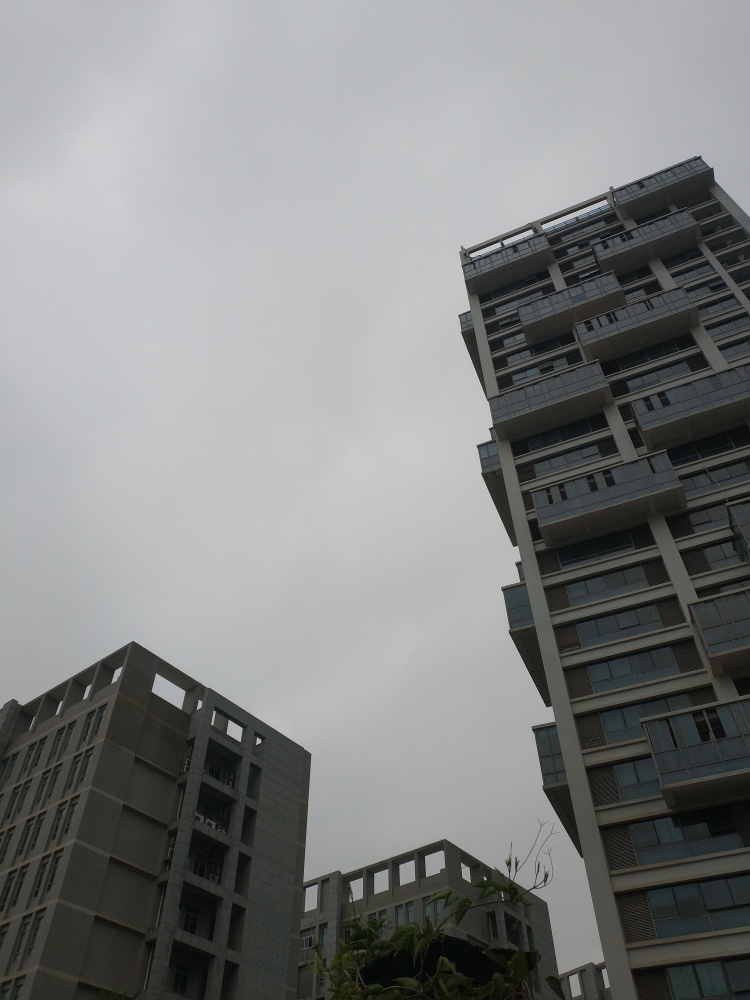Considering the current lighting, what type of photography would be best suited to this setting? This setting lends itself well to moody and atmospheric photography. Photographers looking to capture images with soft, diffused light would find the conditions ideal. The absence of harsh shadows could help in taking portraiture or architectural photos that convey a sense of tranquility or melancholy. 